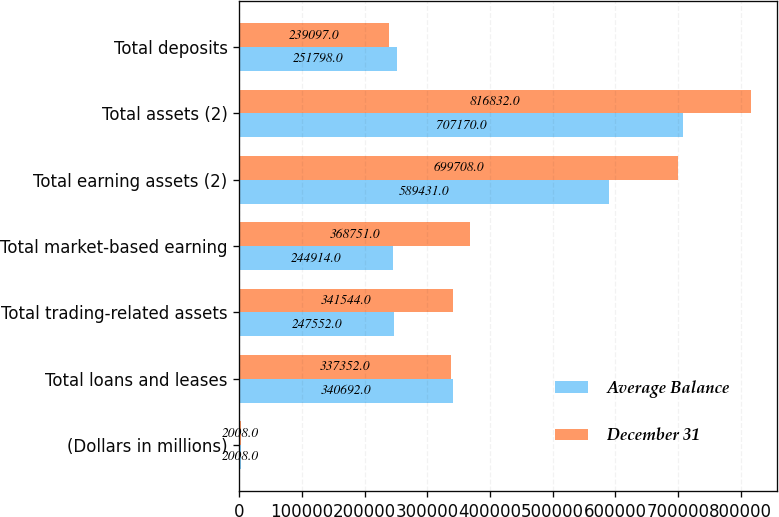Convert chart to OTSL. <chart><loc_0><loc_0><loc_500><loc_500><stacked_bar_chart><ecel><fcel>(Dollars in millions)<fcel>Total loans and leases<fcel>Total trading-related assets<fcel>Total market-based earning<fcel>Total earning assets (2)<fcel>Total assets (2)<fcel>Total deposits<nl><fcel>Average Balance<fcel>2008<fcel>340692<fcel>247552<fcel>244914<fcel>589431<fcel>707170<fcel>251798<nl><fcel>December 31<fcel>2008<fcel>337352<fcel>341544<fcel>368751<fcel>699708<fcel>816832<fcel>239097<nl></chart> 